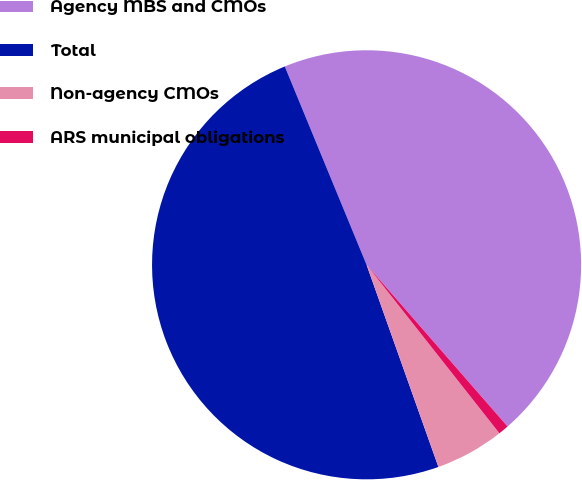Convert chart. <chart><loc_0><loc_0><loc_500><loc_500><pie_chart><fcel>Agency MBS and CMOs<fcel>Total<fcel>Non-agency CMOs<fcel>ARS municipal obligations<nl><fcel>44.81%<fcel>49.21%<fcel>5.19%<fcel>0.79%<nl></chart> 